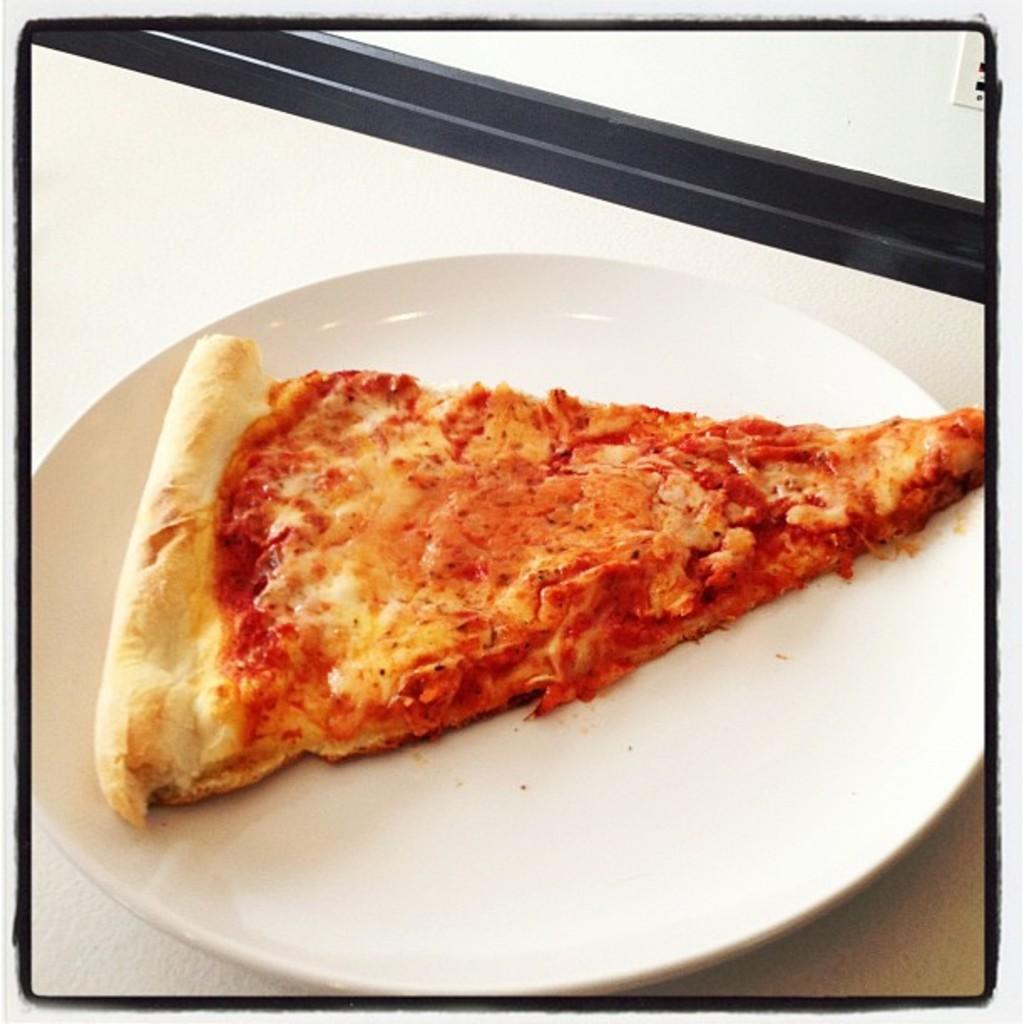What type of food is shown in the image? There is a pizza slice in the image. What color is the plate that the pizza slice is on? The plate is on a white color plate. Where is the plate placed in the image? The plate is on a surface. What type of credit card is shown in the image? There is no credit card present in the image; it only features a pizza slice on a white plate. 